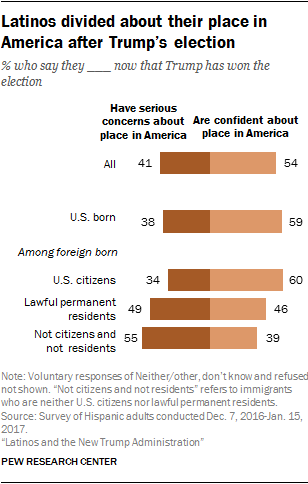Give some essential details in this illustration. According to a recent survey in the United States, 54% of people reported feeling confident about their current place. Out of the total number of issues, those with an approval rate of over 50% are 3. 